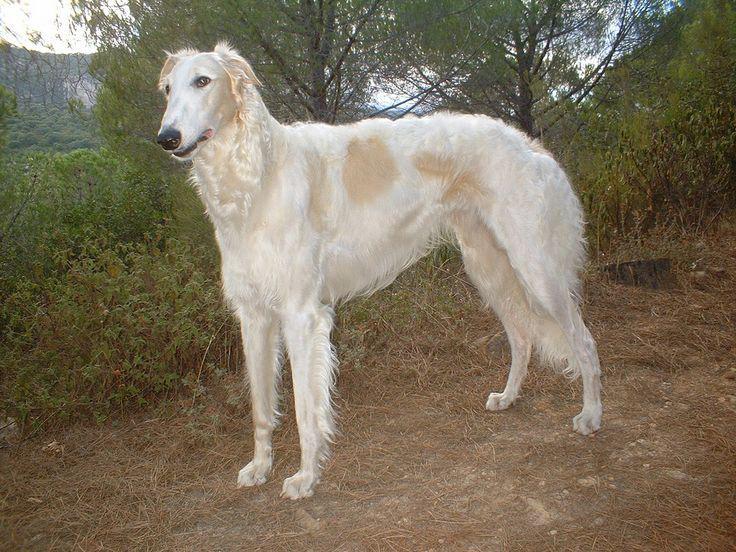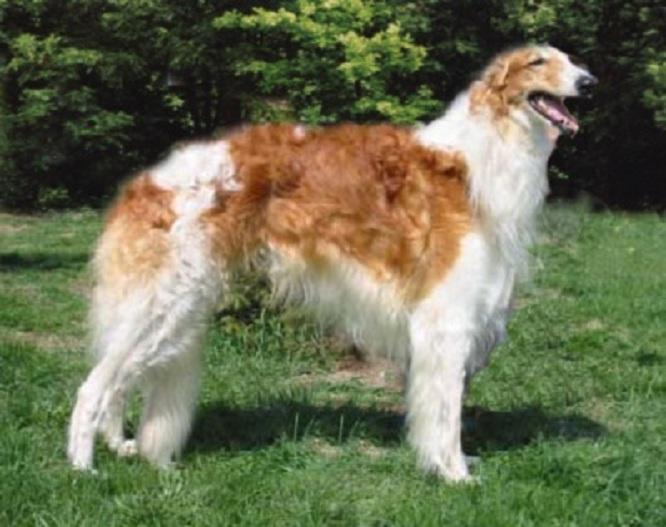The first image is the image on the left, the second image is the image on the right. Assess this claim about the two images: "The combined images include one nearly white dog and one orange-and-white dog, and all dogs are standing in profile looking in the same direction their body is turned.". Correct or not? Answer yes or no. Yes. The first image is the image on the left, the second image is the image on the right. Analyze the images presented: Is the assertion "In at least one image there is a white and light brown dog facing left." valid? Answer yes or no. Yes. 